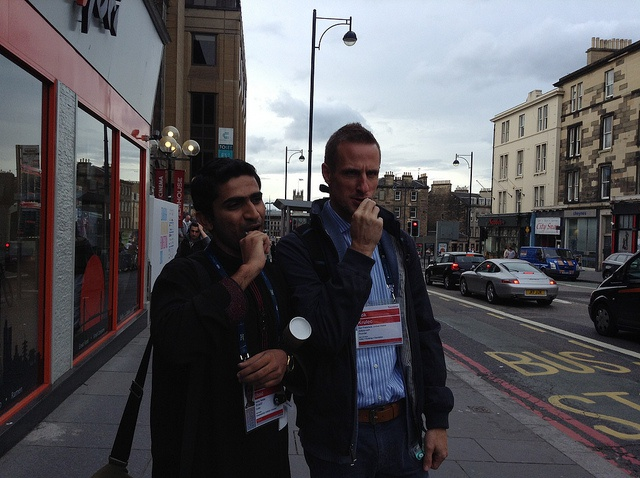Describe the objects in this image and their specific colors. I can see people in gray, black, and maroon tones, people in gray, black, maroon, and brown tones, car in gray, black, and darkgray tones, car in gray and black tones, and handbag in gray and black tones in this image. 